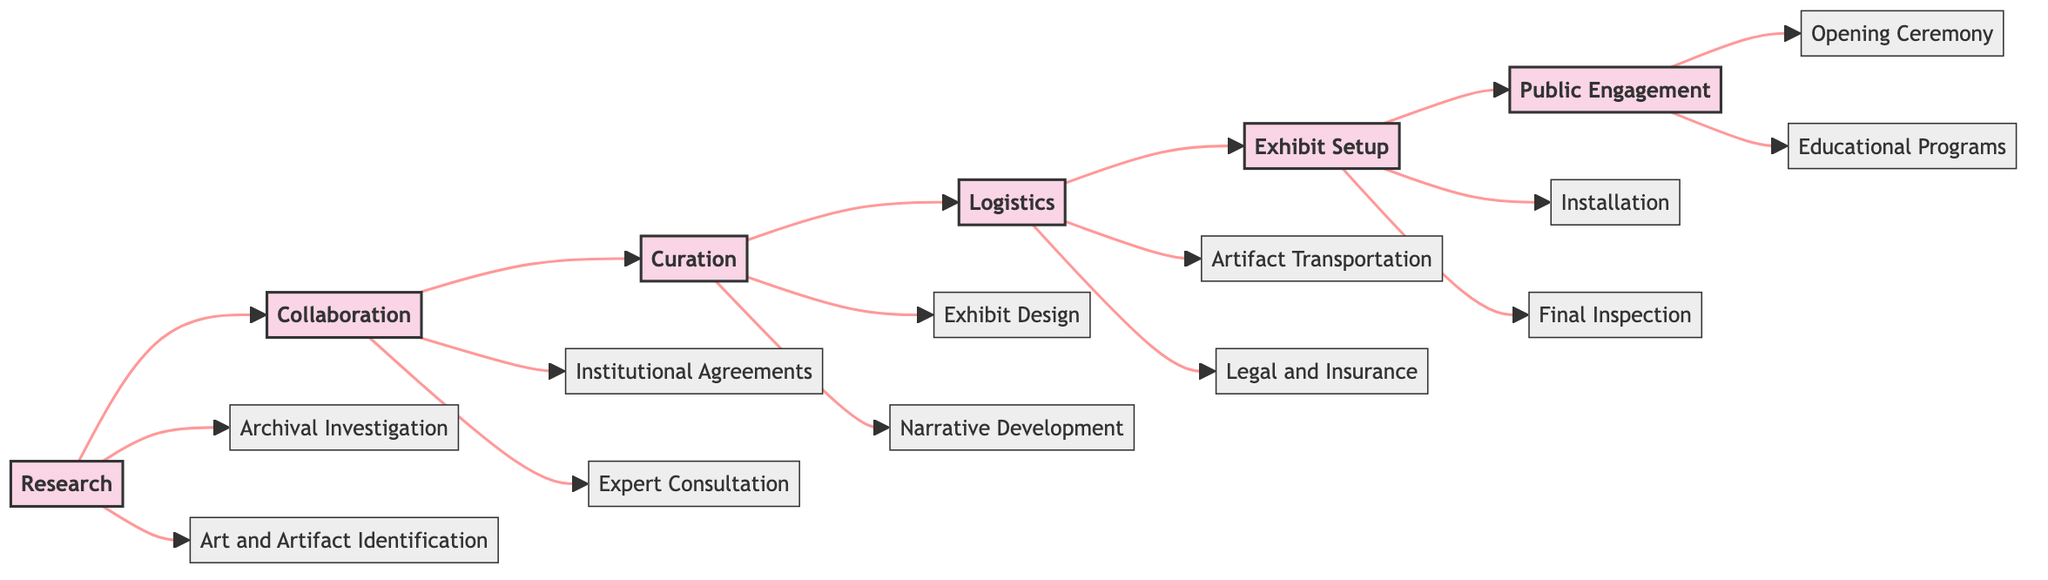What are the phases involved in the workflow? The diagram lists six phases: Research, Collaboration, Curation, Logistics, Exhibit Setup, and Public Engagement.
Answer: Research, Collaboration, Curation, Logistics, Exhibit Setup, Public Engagement How many elements are there in the Research phase? The Research phase contains two elements: Archival Investigation and Art and Artifact Identification. Counting these gives us the answer.
Answer: 2 What is the last phase of the workflow? The last phase in the flowchart is Public Engagement. Following the arrows from the previous phases confirms this.
Answer: Public Engagement Which element is directly linked to the Logistics phase? The Logistics phase has two linked elements: Artifact Transportation and Legal and Insurance. These elements connect directly from the Logistics phase.
Answer: Artifact Transportation, Legal and Insurance Which phase comes before Curation? The Collaboration phase comes directly before the Curation phase, as depicted by the arrows connecting them in the flowchart.
Answer: Collaboration What is the purpose of the Exhibit Design element? Exhibit Design focuses on drafting exhibit blueprints with design firms specializing in historical presentations, derived from its description in the flowchart.
Answer: Drafting exhibit blueprints Which institutions are involved in developing educational programs? The diagram indicates that UNESCO is partnered for the development of educational programs, as mentioned under Public Engagement.
Answer: UNESCO How does the workflow illustrate interconnections between phases? The flowchart visually connects phases with arrows indicating the sequence and flow from one phase to the next, demonstrating order and progression.
Answer: Arrows indicating sequence and flow What element follows the Installation in the Exhibit Setup phase? The Final Inspection follows Installation in the Exhibit Setup phase, as seen in the flowchart's layout.
Answer: Final Inspection 